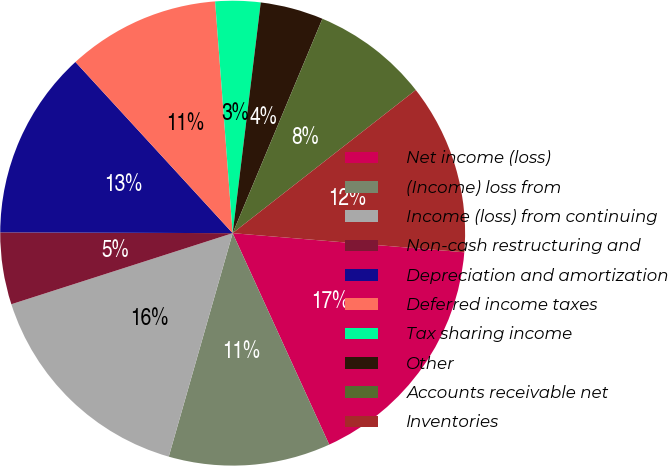<chart> <loc_0><loc_0><loc_500><loc_500><pie_chart><fcel>Net income (loss)<fcel>(Income) loss from<fcel>Income (loss) from continuing<fcel>Non-cash restructuring and<fcel>Depreciation and amortization<fcel>Deferred income taxes<fcel>Tax sharing income<fcel>Other<fcel>Accounts receivable net<fcel>Inventories<nl><fcel>16.87%<fcel>11.25%<fcel>15.62%<fcel>5.0%<fcel>13.12%<fcel>10.62%<fcel>3.13%<fcel>4.38%<fcel>8.13%<fcel>11.87%<nl></chart> 